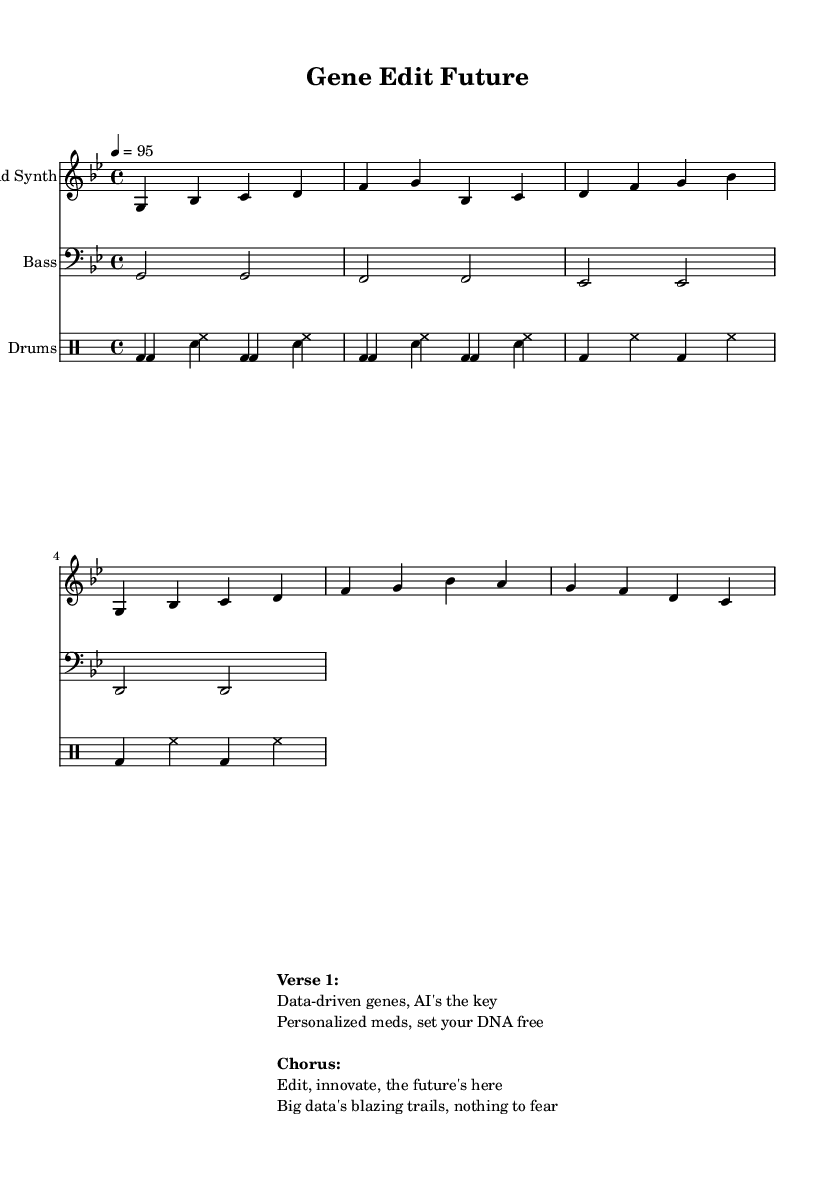What is the key signature of this music? The key signature is indicated at the beginning of the staff; for G minor, there is one flat (B-flat).
Answer: G minor What is the time signature of the piece? The time signature is shown at the beginning of the score, which is 4/4, meaning four beats per measure.
Answer: 4/4 What is the tempo marking for this track? The tempo marking is indicated in the music; it is set to a quarter note equals 95 beats per minute.
Answer: 95 How many measures are in the lead synth part? By counting the vertical lines (bar lines) in the lead synth staff, there are eight measures shown.
Answer: 8 What type of rhythmic instrument is used in the backing? The drumming part is described using a specific drumming notation, which indicates the use of a drum set; commonly referred to in this genre as "Drums."
Answer: Drums What is the theme of the lyrics presented in the verse? The verse discusses the application of data and AI in genetics and personalized medicine, indicating innovation and progress, which aligns with the song’s title.
Answer: Personalized medicine 